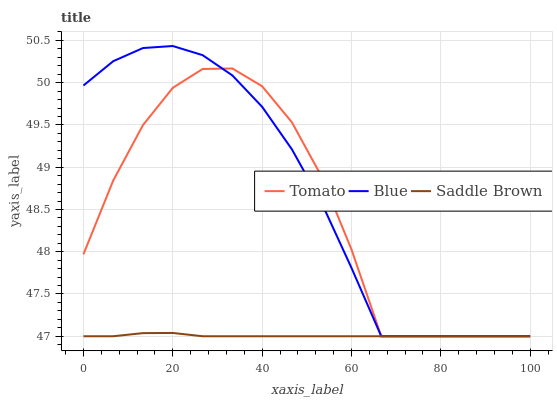Does Saddle Brown have the minimum area under the curve?
Answer yes or no. Yes. Does Blue have the maximum area under the curve?
Answer yes or no. Yes. Does Blue have the minimum area under the curve?
Answer yes or no. No. Does Saddle Brown have the maximum area under the curve?
Answer yes or no. No. Is Saddle Brown the smoothest?
Answer yes or no. Yes. Is Tomato the roughest?
Answer yes or no. Yes. Is Blue the smoothest?
Answer yes or no. No. Is Blue the roughest?
Answer yes or no. No. Does Tomato have the lowest value?
Answer yes or no. Yes. Does Blue have the highest value?
Answer yes or no. Yes. Does Saddle Brown have the highest value?
Answer yes or no. No. Does Blue intersect Tomato?
Answer yes or no. Yes. Is Blue less than Tomato?
Answer yes or no. No. Is Blue greater than Tomato?
Answer yes or no. No. 